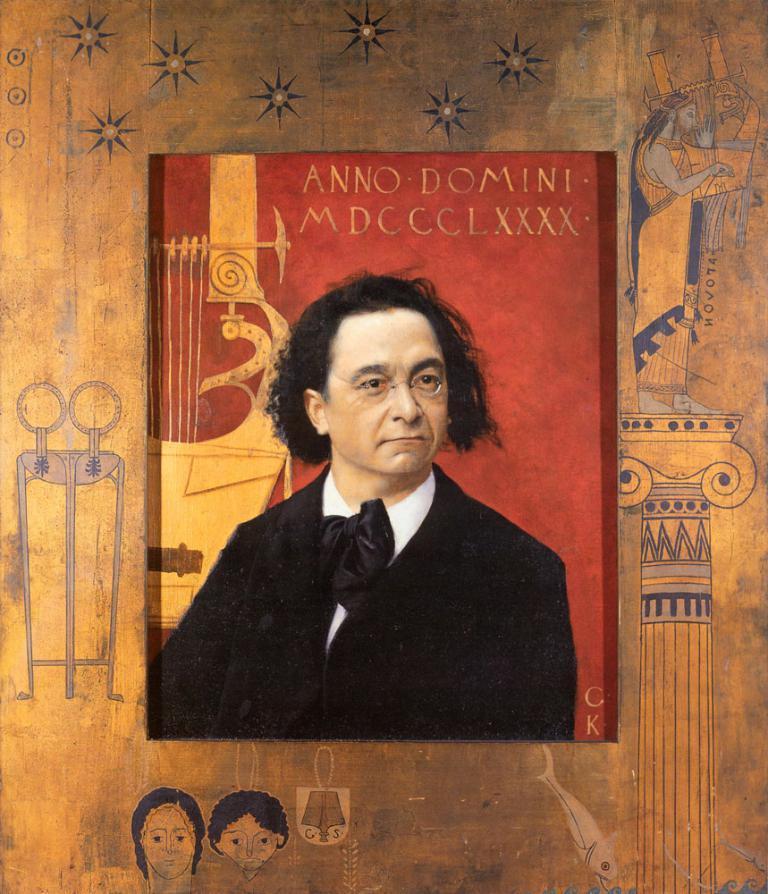Please provide a concise description of this image. In this image we can see a box like object. On that we can see a person wearing specs. Also there is a text. In the back there are drawings on an object. 